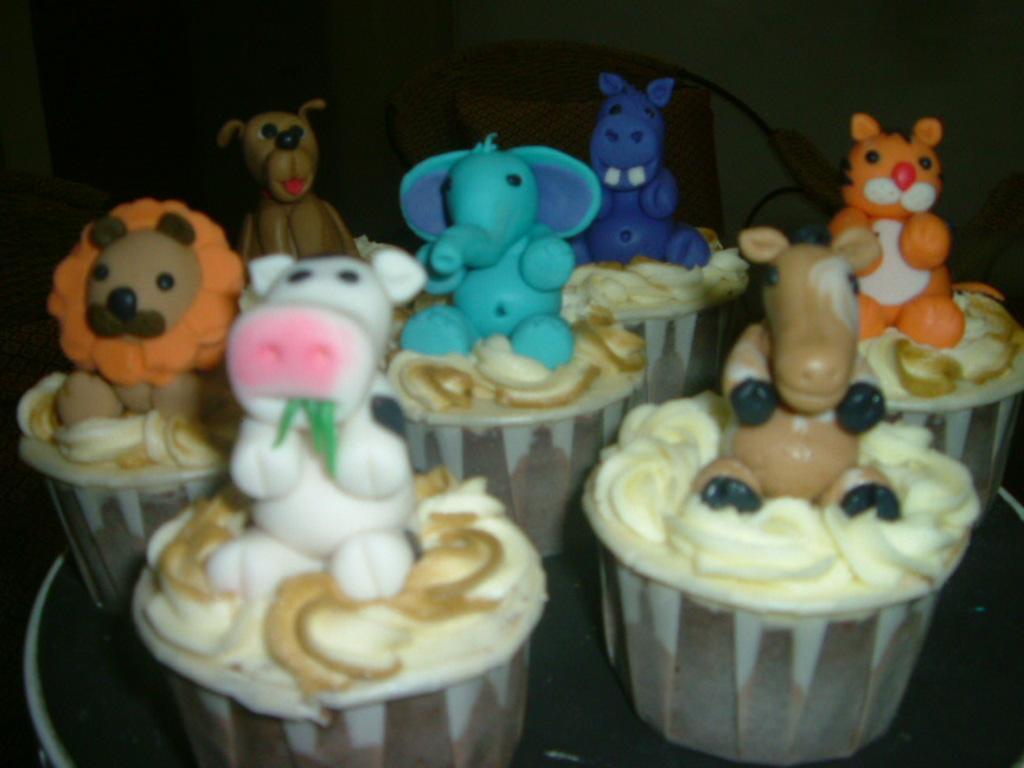Could you give a brief overview of what you see in this image? In this picture we can see there are gumpaste animals on the cupcakes and the cupcakes are on an object. Behind the cupcakes there is a chair and the dark background. 